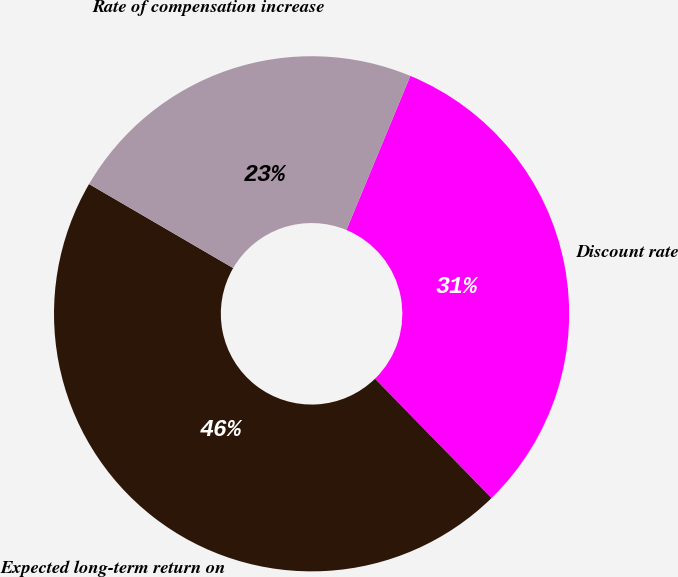Convert chart. <chart><loc_0><loc_0><loc_500><loc_500><pie_chart><fcel>Discount rate<fcel>Expected long-term return on<fcel>Rate of compensation increase<nl><fcel>31.43%<fcel>45.71%<fcel>22.86%<nl></chart> 